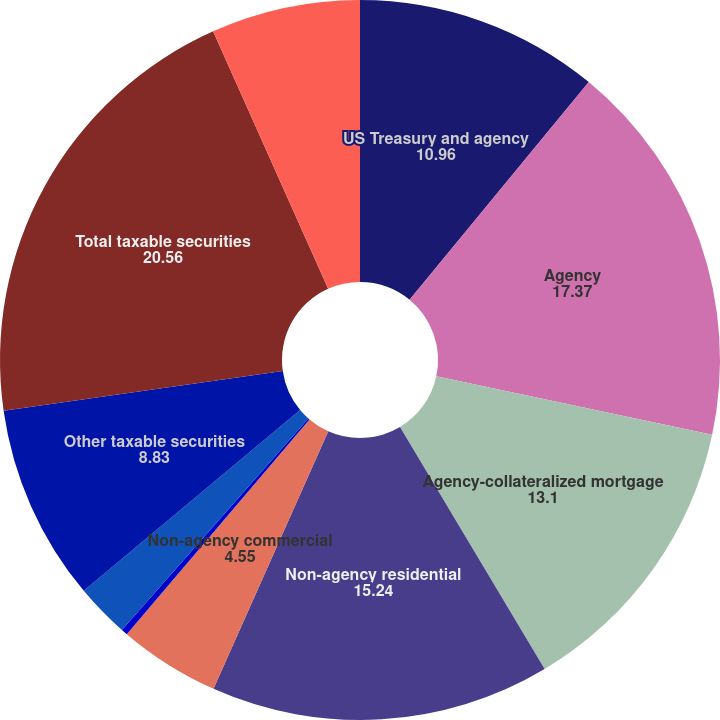Convert chart. <chart><loc_0><loc_0><loc_500><loc_500><pie_chart><fcel>US Treasury and agency<fcel>Agency<fcel>Agency-collateralized mortgage<fcel>Non-agency residential<fcel>Non-agency commercial<fcel>Foreign securities<fcel>Corporate bonds<fcel>Other taxable securities<fcel>Total taxable securities<fcel>Tax-exempt securities (2)<nl><fcel>10.96%<fcel>17.37%<fcel>13.1%<fcel>15.24%<fcel>4.55%<fcel>0.28%<fcel>2.42%<fcel>8.83%<fcel>20.56%<fcel>6.69%<nl></chart> 